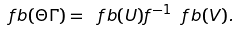<formula> <loc_0><loc_0><loc_500><loc_500>\ f b ( \Theta \Gamma ) = \ f b ( U ) f ^ { - 1 } \ f b ( V ) .</formula> 